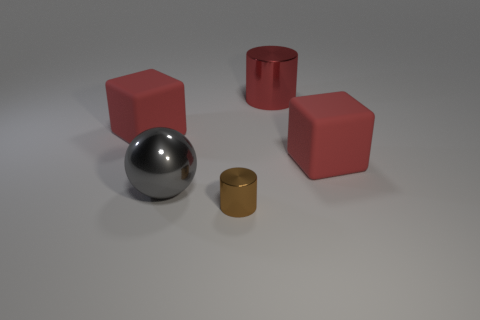Subtract 1 blocks. How many blocks are left? 1 Add 5 small brown metallic objects. How many objects exist? 10 Subtract all brown cylinders. How many cylinders are left? 1 Add 2 red metal things. How many red metal things exist? 3 Subtract 0 gray cubes. How many objects are left? 5 Subtract all spheres. How many objects are left? 4 Subtract all gray cubes. Subtract all yellow balls. How many cubes are left? 2 Subtract all matte blocks. Subtract all red rubber blocks. How many objects are left? 1 Add 3 big objects. How many big objects are left? 7 